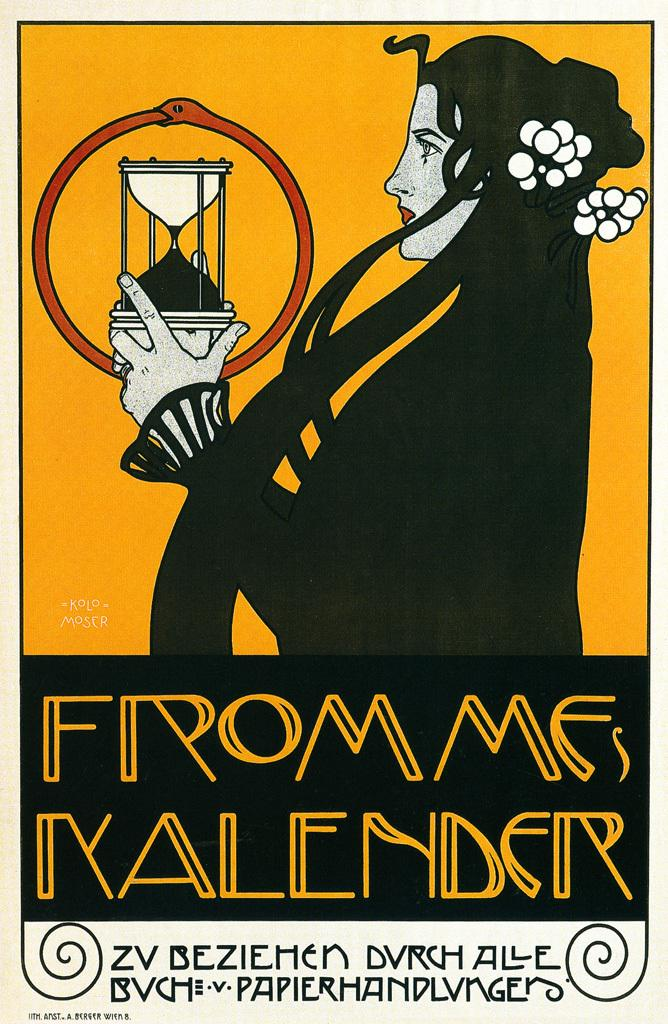<image>
Render a clear and concise summary of the photo. Black and orange book about from mes involving a lady 